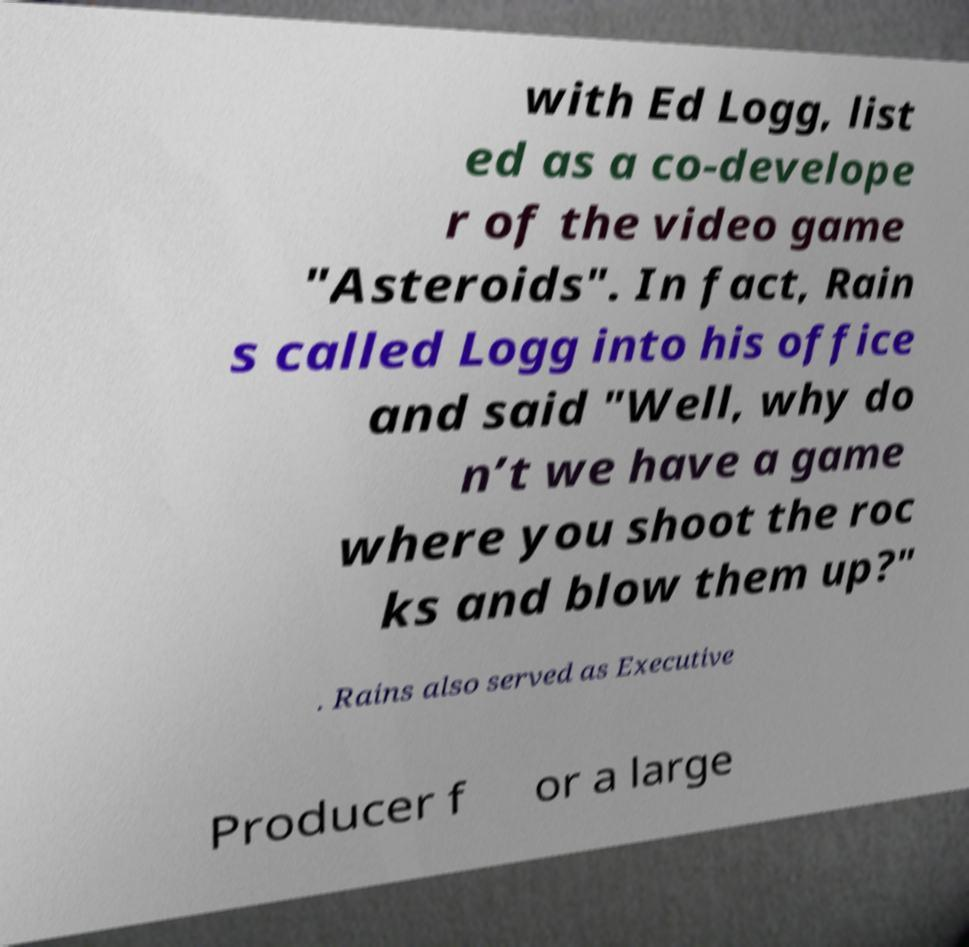Can you accurately transcribe the text from the provided image for me? with Ed Logg, list ed as a co-develope r of the video game "Asteroids". In fact, Rain s called Logg into his office and said "Well, why do n’t we have a game where you shoot the roc ks and blow them up?" . Rains also served as Executive Producer f or a large 